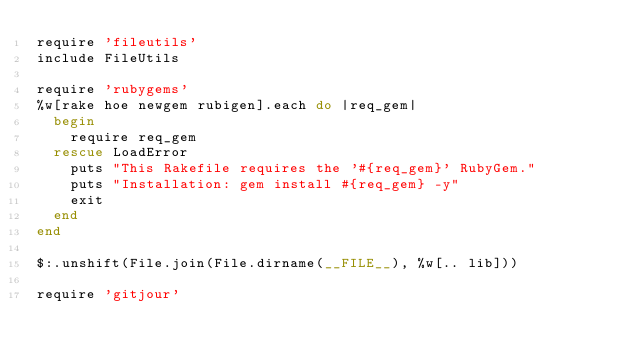<code> <loc_0><loc_0><loc_500><loc_500><_Ruby_>require 'fileutils'
include FileUtils

require 'rubygems'
%w[rake hoe newgem rubigen].each do |req_gem|
  begin
    require req_gem
  rescue LoadError
    puts "This Rakefile requires the '#{req_gem}' RubyGem."
    puts "Installation: gem install #{req_gem} -y"
    exit
  end
end

$:.unshift(File.join(File.dirname(__FILE__), %w[.. lib]))

require 'gitjour'</code> 